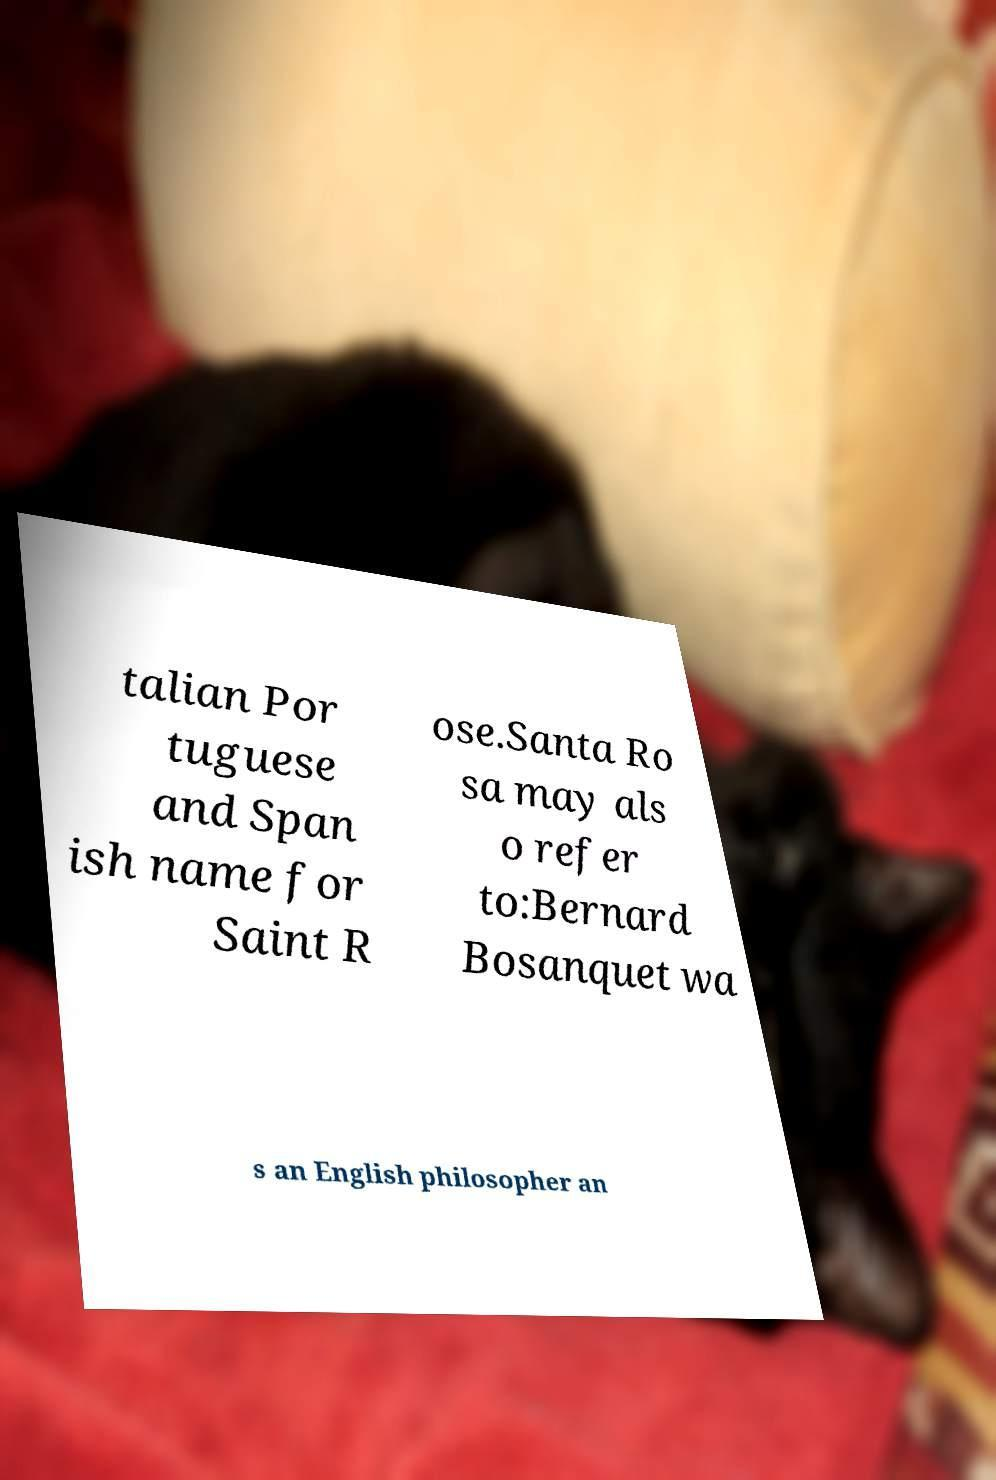What messages or text are displayed in this image? I need them in a readable, typed format. talian Por tuguese and Span ish name for Saint R ose.Santa Ro sa may als o refer to:Bernard Bosanquet wa s an English philosopher an 